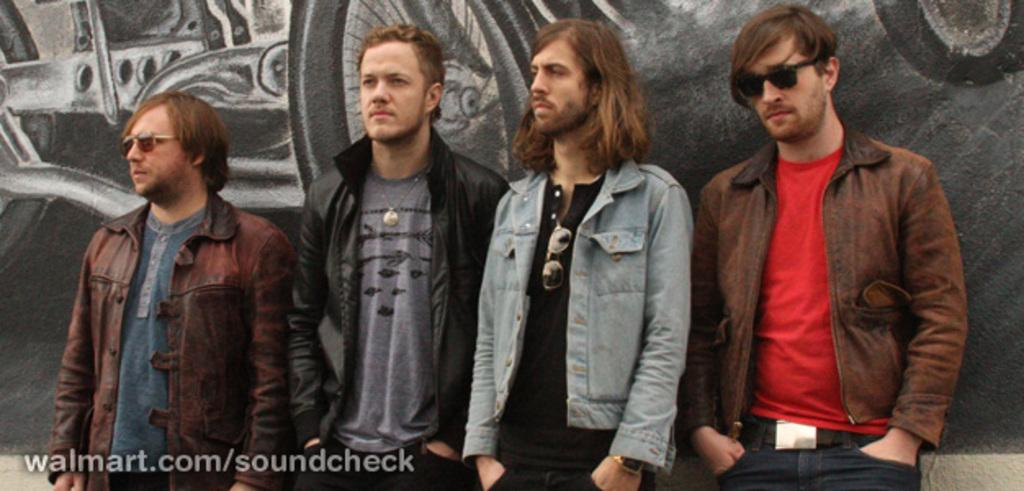What can be seen in the image regarding the people? There are persons wearing clothes in the image. What is visible in the background of the image? There is a wall with art in the background of the image. Where is the text located in the image? The text is in the bottom left of the image. What type of discussion is taking place between the persons in the image? There is no discussion taking place in the image; it only shows people wearing clothes and a wall with art in the background. 